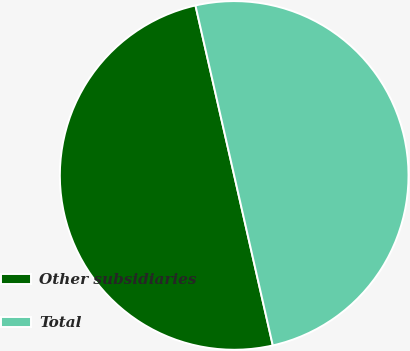Convert chart. <chart><loc_0><loc_0><loc_500><loc_500><pie_chart><fcel>Other subsidiaries<fcel>Total<nl><fcel>49.99%<fcel>50.01%<nl></chart> 